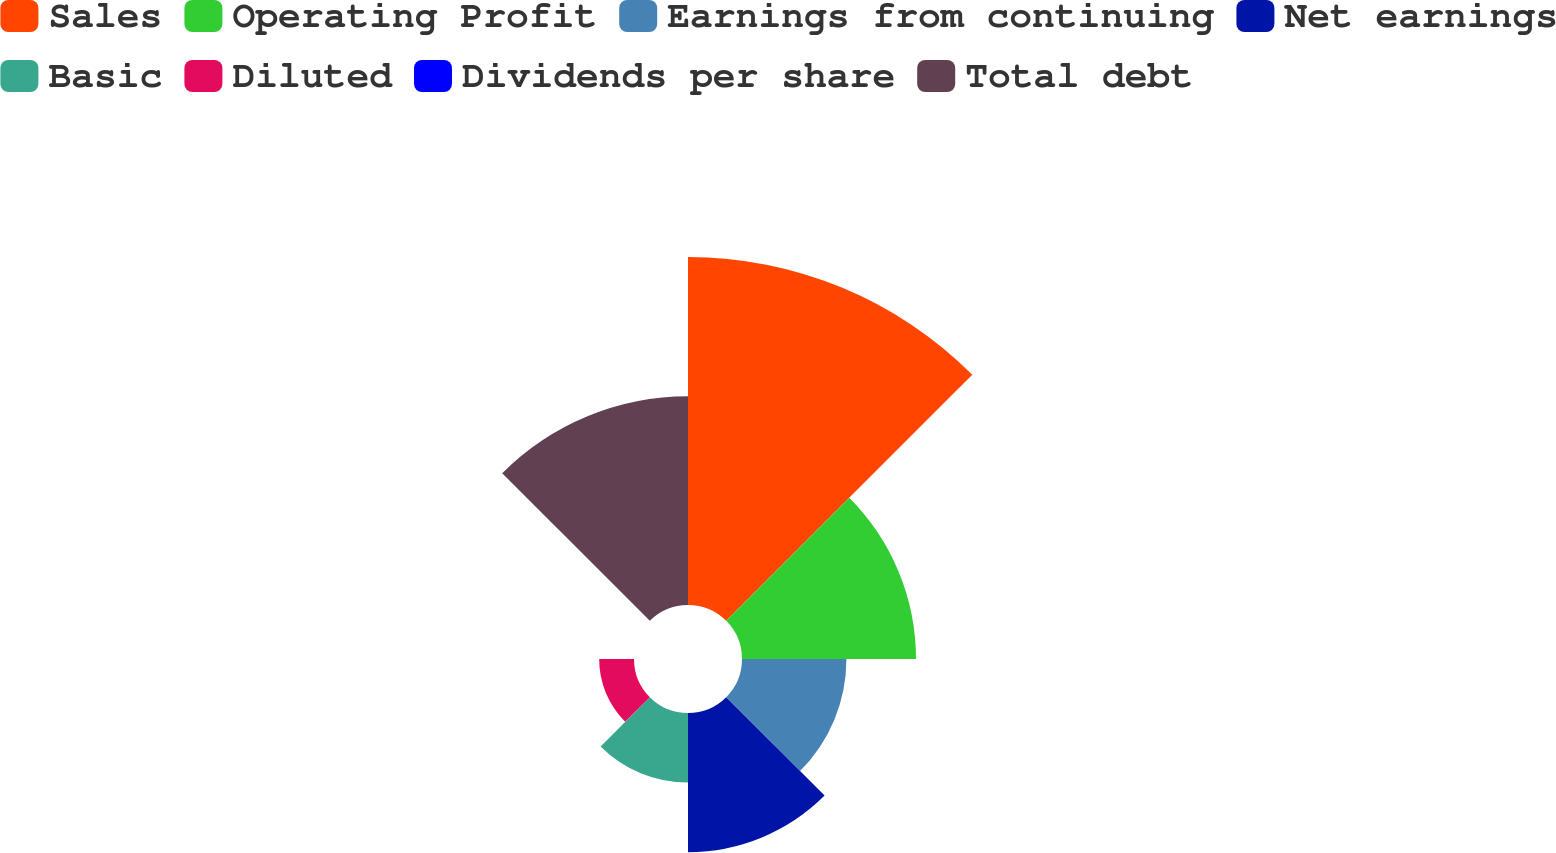<chart> <loc_0><loc_0><loc_500><loc_500><pie_chart><fcel>Sales<fcel>Operating Profit<fcel>Earnings from continuing<fcel>Net earnings<fcel>Basic<fcel>Diluted<fcel>Dividends per share<fcel>Total debt<nl><fcel>32.26%<fcel>16.13%<fcel>9.68%<fcel>12.9%<fcel>6.45%<fcel>3.23%<fcel>0.0%<fcel>19.35%<nl></chart> 